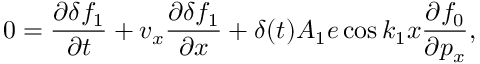<formula> <loc_0><loc_0><loc_500><loc_500>0 = \frac { \partial \delta f _ { 1 } } { \partial t } + v _ { x } \frac { \partial \delta f _ { 1 } } { \partial x } + \delta ( t ) A _ { 1 } e \cos k _ { 1 } x \frac { \partial f _ { 0 } } { \partial p _ { x } } ,</formula> 